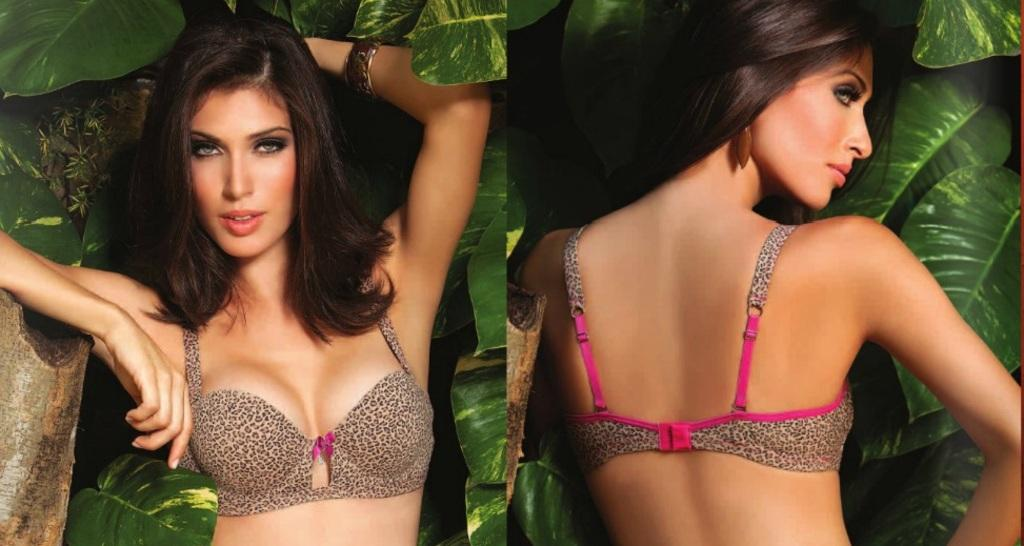What is the composition of the image? The image is a collage of two different pictures. Who is depicted in both pictures? Both pictures depict the same person. How is the person shown in the first picture? In the first picture, the person is shown in a front view. How is the person shown in the second picture? In the second picture, the person is shown in a back view. What type of mint can be seen growing in the image? There is no mint present in the image; it is a collage of two pictures depicting the same person from different angles. 